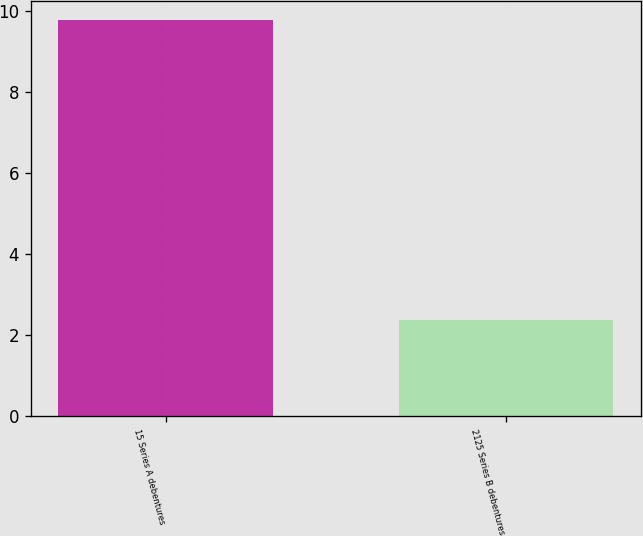Convert chart. <chart><loc_0><loc_0><loc_500><loc_500><bar_chart><fcel>15 Series A debentures<fcel>2125 Series B debentures<nl><fcel>9.76<fcel>2.36<nl></chart> 